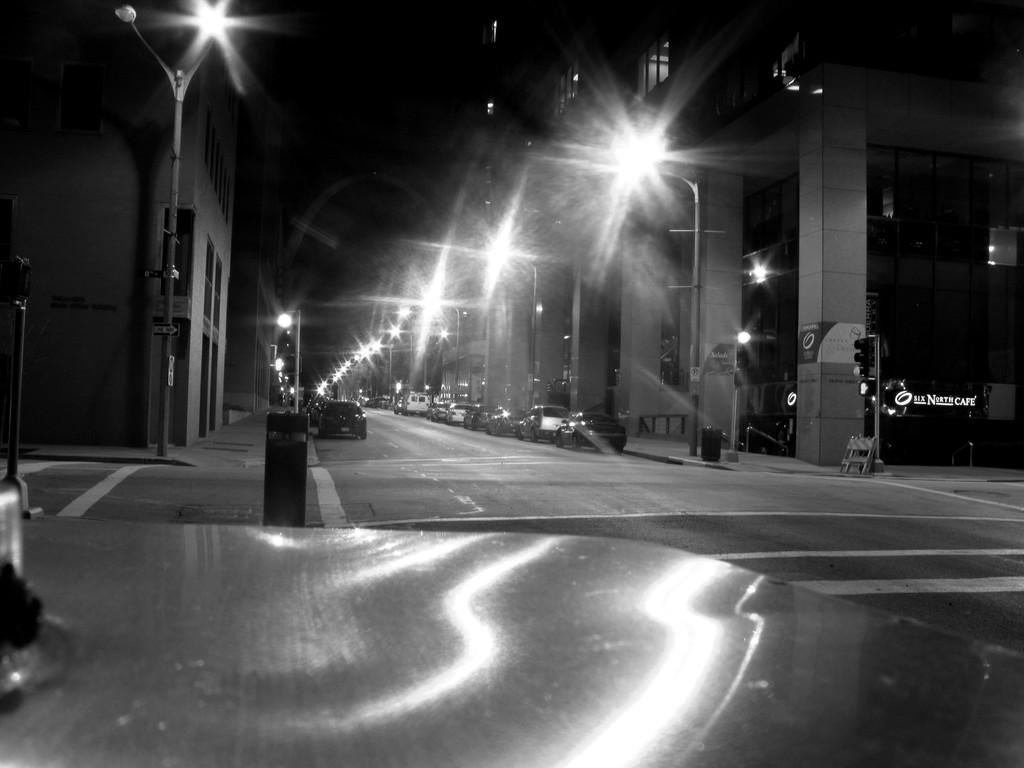What is the object located in front of the image? The facts do not specify the object in front of the image. What can be seen on the road in the image? There are cars on the road in the image. What helps control traffic in the image? There are traffic lights in the image. What provides illumination in the image? There are light poles in the image. What can be used for waste disposal in the image? There are dustbins in the image. What helps people navigate in the image? There are directional boards in the image. What type of structures are visible in the image? There are buildings in the image. What type of barrier is present in the image? There is a metal fence in the image. How does the uncle stretch in the image? There is no uncle present in the image, and therefore no stretching can be observed. 